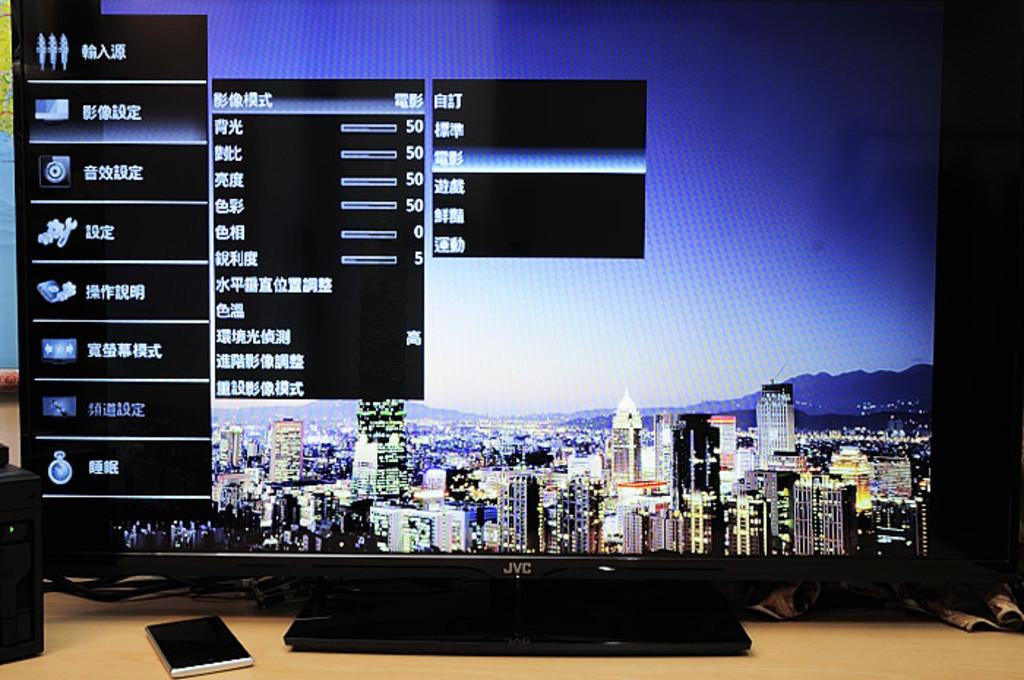<image>
Relay a brief, clear account of the picture shown. a television that has some Japanese writing on it 